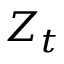Convert formula to latex. <formula><loc_0><loc_0><loc_500><loc_500>Z _ { t }</formula> 